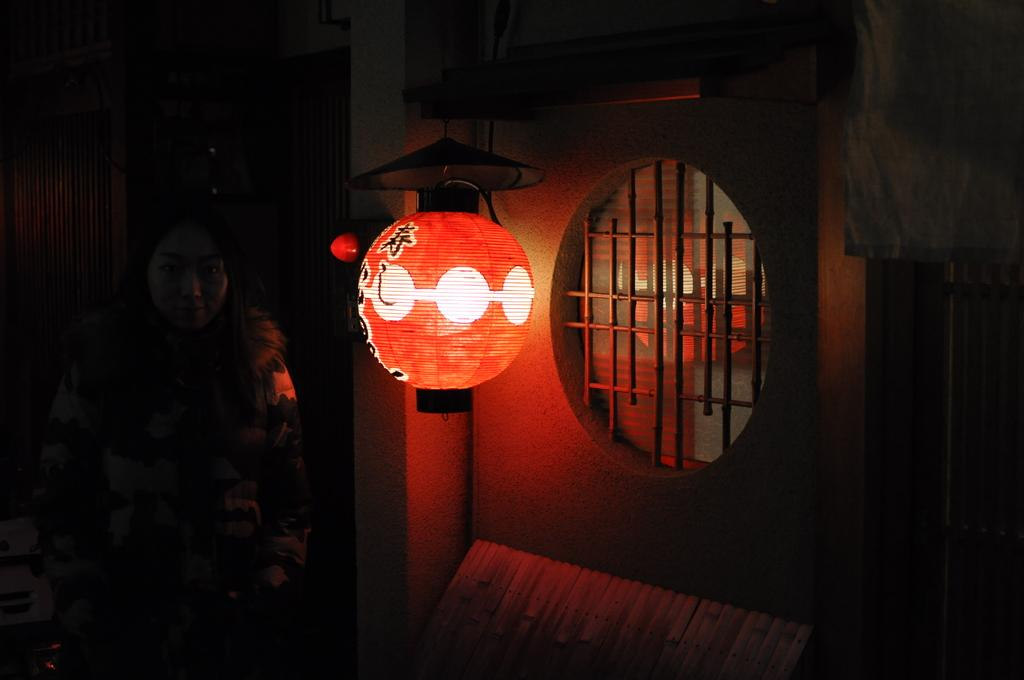What can be seen in the image that provides illumination? There is a light in the image. What is located on the right side of the image? There is there a window on the right side of the image. Who is present on the left side of the image? There is a woman on the left side of the image. How would you describe the overall lighting in the image? The background of the image is dark. How many tin feet are visible in the image? There are no tin feet present in the image. 